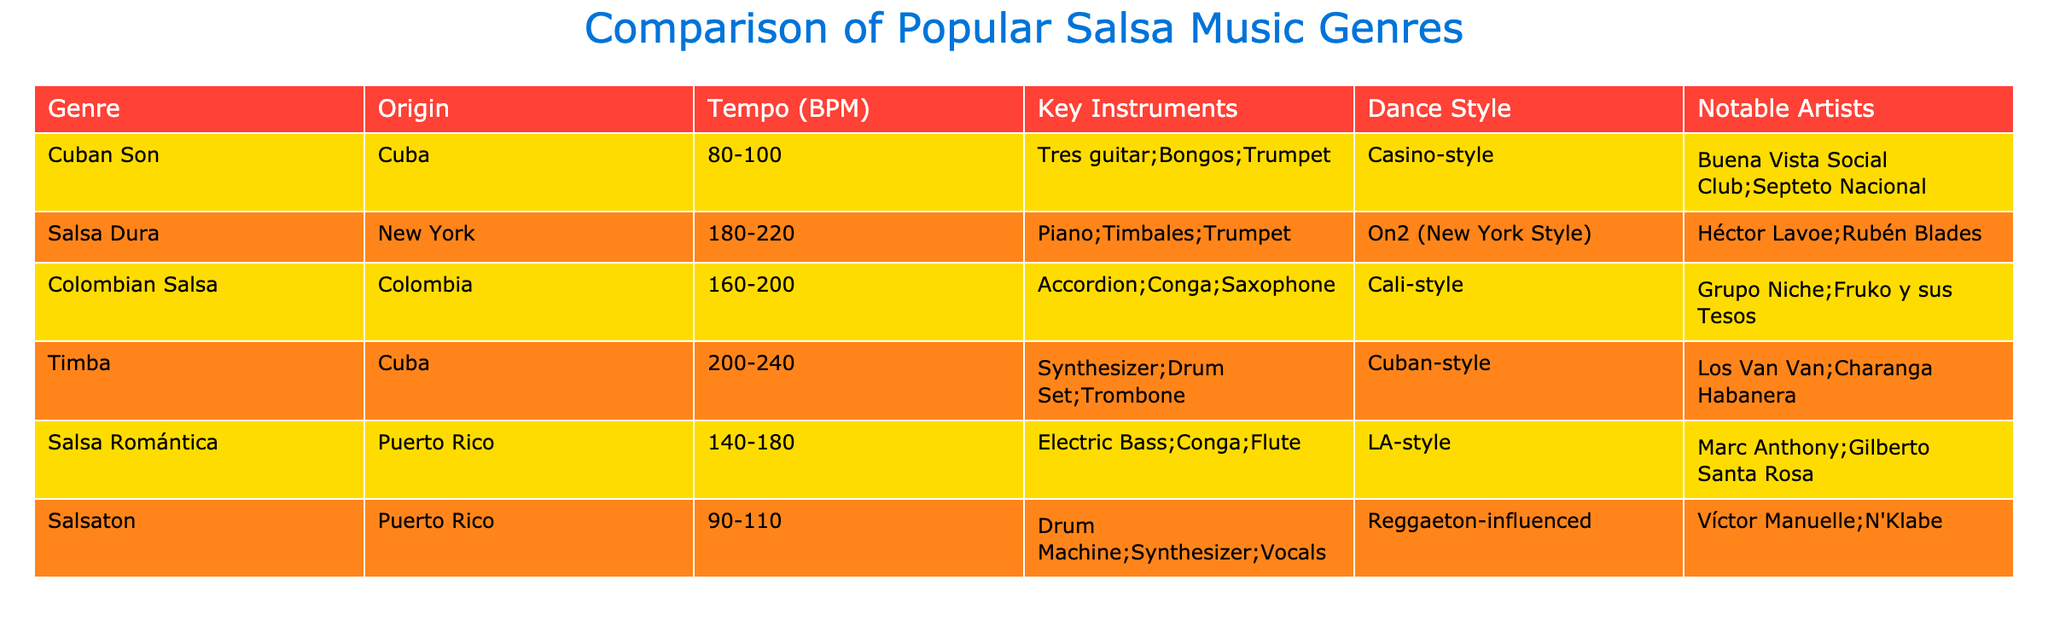What is the origin of Salsa Dura? According to the table, Salsa Dura originates from New York.
Answer: New York Which genre has the highest tempo? The tempo of Timba ranges from 200 to 240 BPM, which is the highest compared to other genres listed in the table.
Answer: Timba What are the key instruments used in Salsa Romántica? The table lists the key instruments for Salsa Romántica as Electric Bass, Conga, and Flute.
Answer: Electric Bass, Conga, Flute Is Cuban Son faster than Colombian Salsa? The tempo for Cuban Son is 80-100 BPM, while Colombian Salsa ranges from 160-200 BPM. Therefore, Cuban Son is not faster; it is slower.
Answer: No Which two genres are influenced by Reggaeton? The table shows that Salsaton is specifically mentioned as being influenced by Reggaeton, but no other genre listed mentions Reggaeton influence.
Answer: Salsaton What is the average tempo for all the salsa genres listed? The tempos for each genre are: 80-100 (90), 180-220 (200), 160-200 (180), 200-240 (220), 140-180 (160), and 90-110 (100). The average is calculated by converting the ranges to midpoints and then averaging: (90 + 200 + 180 + 220 + 160 + 100) / 6 = 175.
Answer: 175 Which genre includes the Trombone as a key instrument? The table indicates that Timba is the genre featuring Trombone among its key instruments.
Answer: Timba Are there any notable artists associated with Cuban Son? Yes, the table lists Buena Vista Social Club and Septeto Nacional as notable artists associated with Cuban Son.
Answer: Yes What is the most common dance style among these salsa genres? By examining the dance styles listed, it appears Casino-style, On2 (New York Style), Cali-style, Cuban-style, LA-style, and Reggaeton-influenced are all distinct. No one style dominates.
Answer: No common style 